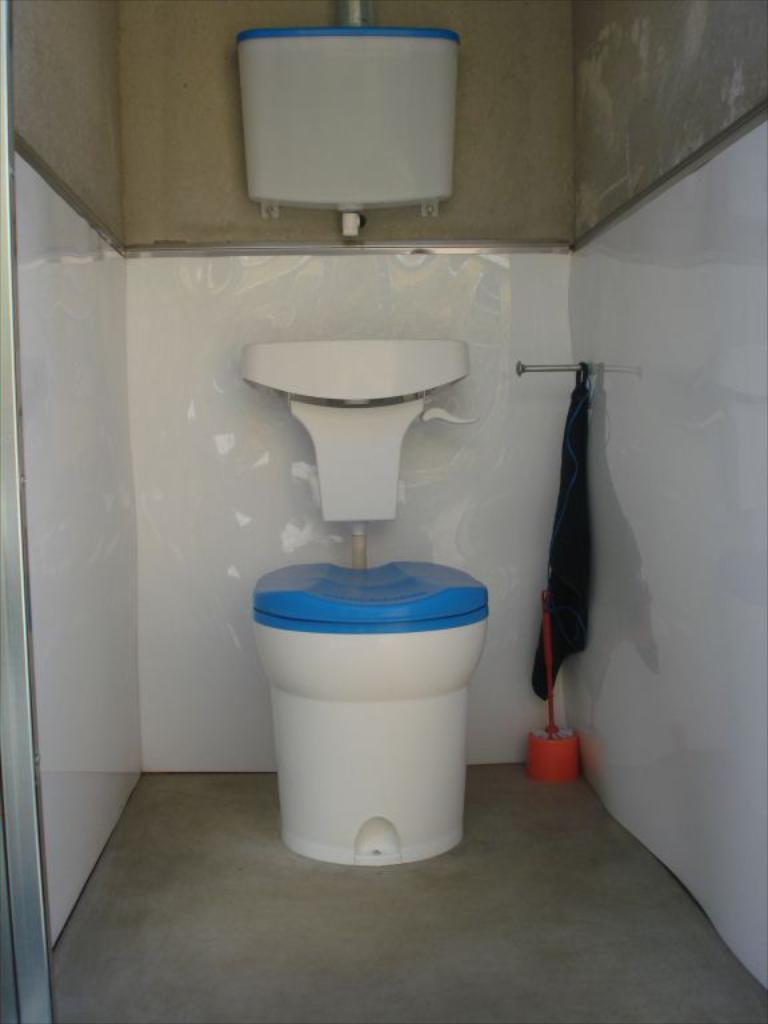What is the main object in the image? There is a toilet seat in the image. What is located above the toilet seat? There is a flush tank in the image. What cleaning tool is present in the image? There is a toilet brush in the image. What can be seen in the background of the image? There is a wall in the background of the image. How many apples are hanging from the flush tank in the image? There are no apples present in the image, let alone hanging from the flush tank. 